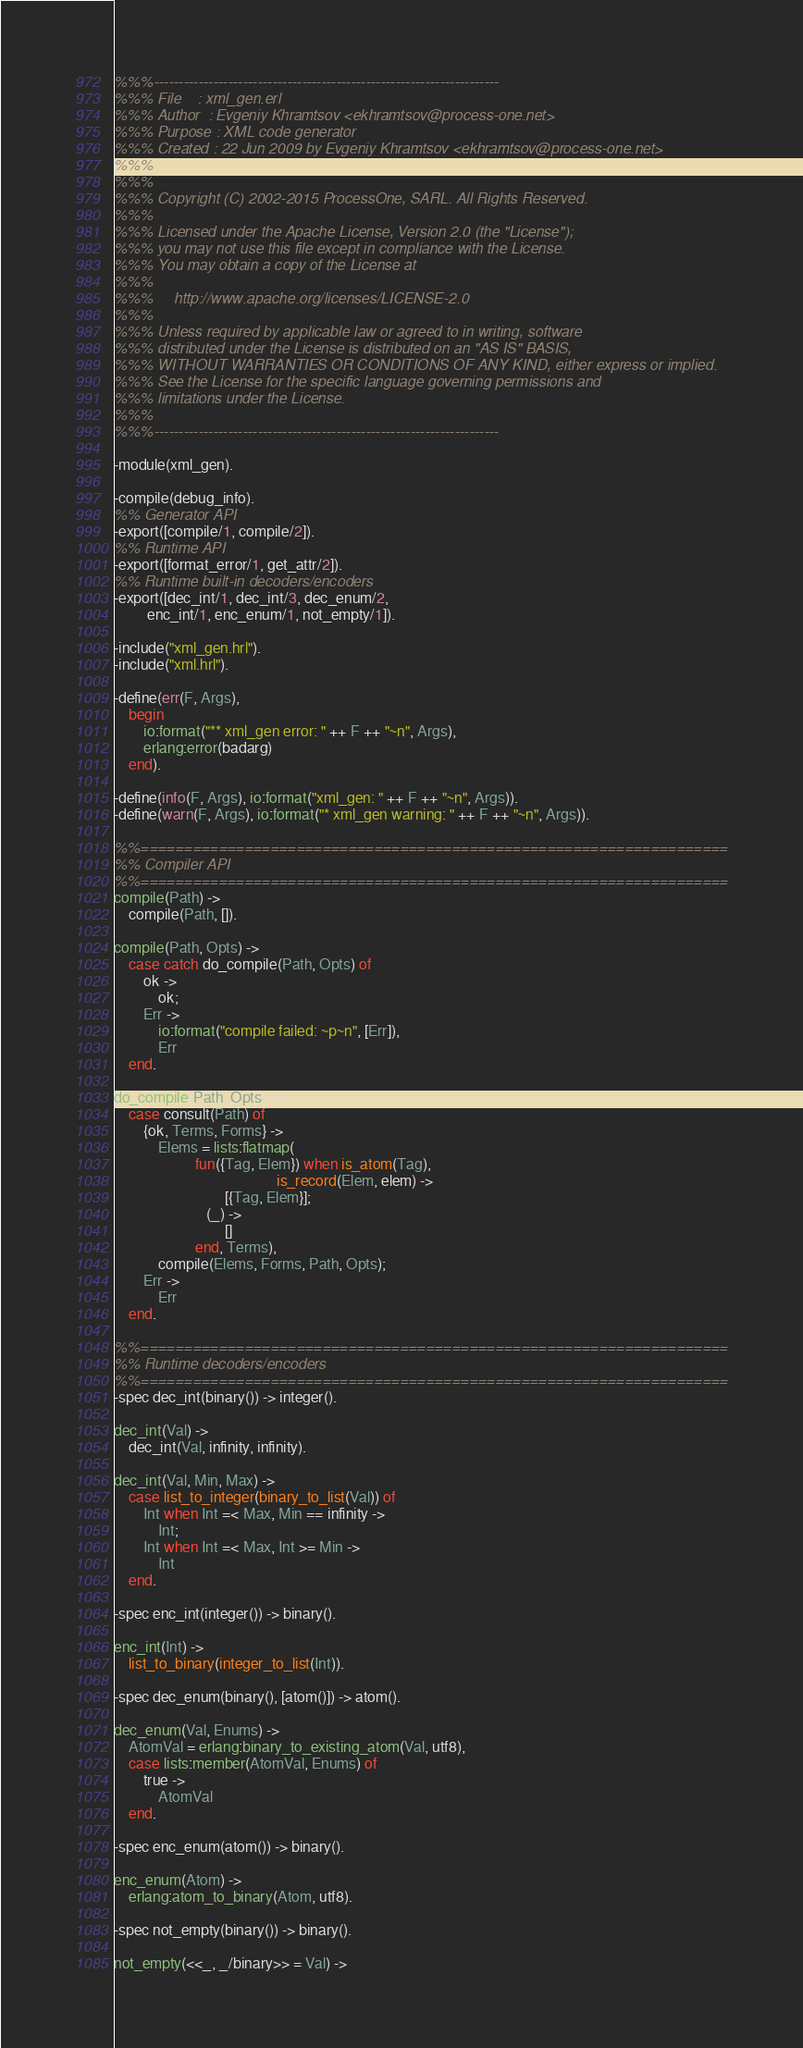Convert code to text. <code><loc_0><loc_0><loc_500><loc_500><_Erlang_>%%%----------------------------------------------------------------------
%%% File    : xml_gen.erl
%%% Author  : Evgeniy Khramtsov <ekhramtsov@process-one.net>
%%% Purpose : XML code generator
%%% Created : 22 Jun 2009 by Evgeniy Khramtsov <ekhramtsov@process-one.net>
%%%
%%%
%%% Copyright (C) 2002-2015 ProcessOne, SARL. All Rights Reserved.
%%%
%%% Licensed under the Apache License, Version 2.0 (the "License");
%%% you may not use this file except in compliance with the License.
%%% You may obtain a copy of the License at
%%%
%%%     http://www.apache.org/licenses/LICENSE-2.0
%%%
%%% Unless required by applicable law or agreed to in writing, software
%%% distributed under the License is distributed on an "AS IS" BASIS,
%%% WITHOUT WARRANTIES OR CONDITIONS OF ANY KIND, either express or implied.
%%% See the License for the specific language governing permissions and
%%% limitations under the License.
%%%
%%%----------------------------------------------------------------------

-module(xml_gen).

-compile(debug_info).
%% Generator API
-export([compile/1, compile/2]).
%% Runtime API
-export([format_error/1, get_attr/2]).
%% Runtime built-in decoders/encoders
-export([dec_int/1, dec_int/3, dec_enum/2,
         enc_int/1, enc_enum/1, not_empty/1]).

-include("xml_gen.hrl").
-include("xml.hrl").

-define(err(F, Args),
	begin
	    io:format("** xml_gen error: " ++ F ++ "~n", Args),
	    erlang:error(badarg)
	end).

-define(info(F, Args), io:format("xml_gen: " ++ F ++ "~n", Args)).
-define(warn(F, Args), io:format("* xml_gen warning: " ++ F ++ "~n", Args)).

%%====================================================================
%% Compiler API
%%====================================================================
compile(Path) ->
    compile(Path, []).

compile(Path, Opts) ->
    case catch do_compile(Path, Opts) of
        ok ->
            ok;
        Err ->
            io:format("compile failed: ~p~n", [Err]),
            Err
    end.

do_compile(Path, Opts) ->
    case consult(Path) of
        {ok, Terms, Forms} ->
            Elems = lists:flatmap(
                      fun({Tag, Elem}) when is_atom(Tag),
                                            is_record(Elem, elem) ->
                              [{Tag, Elem}];
                         (_) ->
                              []
                      end, Terms),
            compile(Elems, Forms, Path, Opts);
        Err ->
            Err
    end.

%%====================================================================
%% Runtime decoders/encoders
%%====================================================================
-spec dec_int(binary()) -> integer().

dec_int(Val) ->
    dec_int(Val, infinity, infinity).

dec_int(Val, Min, Max) ->
    case list_to_integer(binary_to_list(Val)) of
        Int when Int =< Max, Min == infinity ->
            Int;
        Int when Int =< Max, Int >= Min ->
            Int
    end.

-spec enc_int(integer()) -> binary().

enc_int(Int) ->
    list_to_binary(integer_to_list(Int)).

-spec dec_enum(binary(), [atom()]) -> atom().

dec_enum(Val, Enums) ->
    AtomVal = erlang:binary_to_existing_atom(Val, utf8),
    case lists:member(AtomVal, Enums) of
        true ->
            AtomVal
    end.

-spec enc_enum(atom()) -> binary().

enc_enum(Atom) ->
    erlang:atom_to_binary(Atom, utf8).

-spec not_empty(binary()) -> binary().

not_empty(<<_, _/binary>> = Val) -></code> 